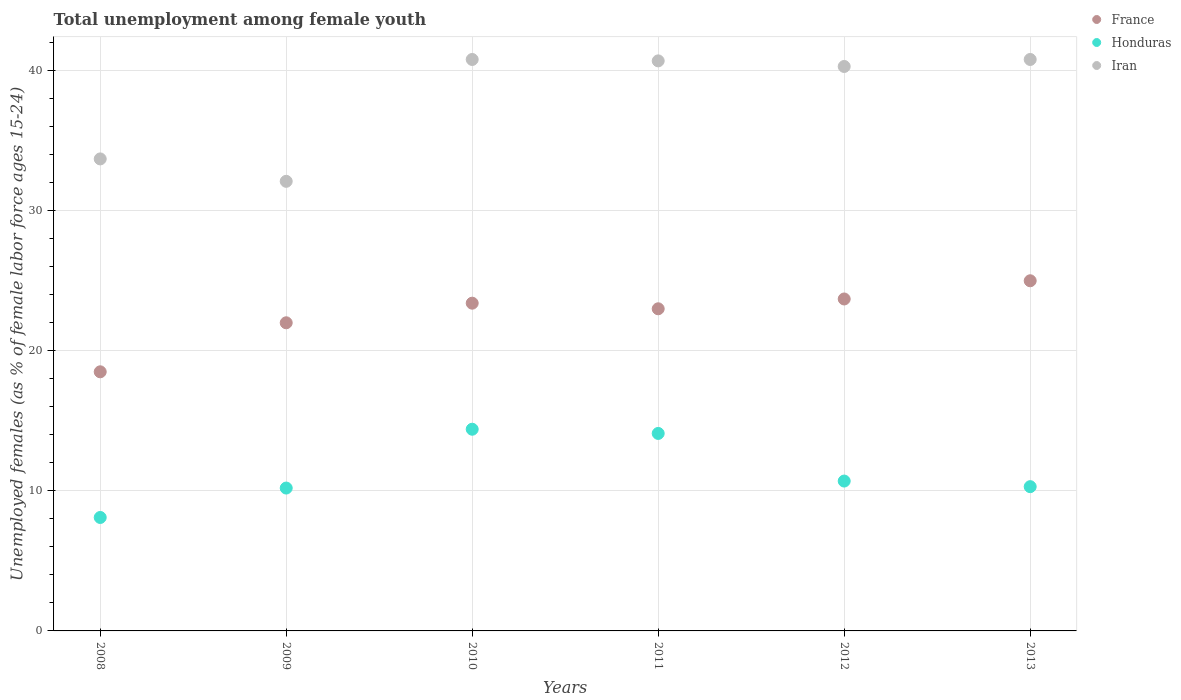Is the number of dotlines equal to the number of legend labels?
Ensure brevity in your answer.  Yes. What is the percentage of unemployed females in in Honduras in 2010?
Your answer should be very brief. 14.4. Across all years, what is the maximum percentage of unemployed females in in Honduras?
Provide a succinct answer. 14.4. In which year was the percentage of unemployed females in in France maximum?
Provide a succinct answer. 2013. What is the total percentage of unemployed females in in France in the graph?
Your answer should be compact. 135.6. What is the difference between the percentage of unemployed females in in Iran in 2009 and that in 2013?
Provide a succinct answer. -8.7. What is the difference between the percentage of unemployed females in in France in 2013 and the percentage of unemployed females in in Honduras in 2008?
Offer a very short reply. 16.9. What is the average percentage of unemployed females in in Iran per year?
Your answer should be very brief. 38.07. In the year 2009, what is the difference between the percentage of unemployed females in in Iran and percentage of unemployed females in in France?
Offer a terse response. 10.1. What is the ratio of the percentage of unemployed females in in Iran in 2008 to that in 2010?
Give a very brief answer. 0.83. Is the percentage of unemployed females in in Iran in 2009 less than that in 2013?
Your response must be concise. Yes. What is the difference between the highest and the second highest percentage of unemployed females in in France?
Ensure brevity in your answer.  1.3. Is it the case that in every year, the sum of the percentage of unemployed females in in Iran and percentage of unemployed females in in Honduras  is greater than the percentage of unemployed females in in France?
Keep it short and to the point. Yes. Does the percentage of unemployed females in in France monotonically increase over the years?
Ensure brevity in your answer.  No. Is the percentage of unemployed females in in Honduras strictly greater than the percentage of unemployed females in in Iran over the years?
Your answer should be very brief. No. How many dotlines are there?
Your answer should be compact. 3. How many years are there in the graph?
Ensure brevity in your answer.  6. What is the difference between two consecutive major ticks on the Y-axis?
Your answer should be very brief. 10. Are the values on the major ticks of Y-axis written in scientific E-notation?
Keep it short and to the point. No. Does the graph contain grids?
Give a very brief answer. Yes. Where does the legend appear in the graph?
Make the answer very short. Top right. How many legend labels are there?
Ensure brevity in your answer.  3. What is the title of the graph?
Ensure brevity in your answer.  Total unemployment among female youth. Does "Comoros" appear as one of the legend labels in the graph?
Make the answer very short. No. What is the label or title of the X-axis?
Ensure brevity in your answer.  Years. What is the label or title of the Y-axis?
Offer a terse response. Unemployed females (as % of female labor force ages 15-24). What is the Unemployed females (as % of female labor force ages 15-24) of France in 2008?
Offer a very short reply. 18.5. What is the Unemployed females (as % of female labor force ages 15-24) of Honduras in 2008?
Offer a terse response. 8.1. What is the Unemployed females (as % of female labor force ages 15-24) of Iran in 2008?
Make the answer very short. 33.7. What is the Unemployed females (as % of female labor force ages 15-24) of France in 2009?
Provide a short and direct response. 22. What is the Unemployed females (as % of female labor force ages 15-24) of Honduras in 2009?
Provide a succinct answer. 10.2. What is the Unemployed females (as % of female labor force ages 15-24) of Iran in 2009?
Your answer should be compact. 32.1. What is the Unemployed females (as % of female labor force ages 15-24) in France in 2010?
Keep it short and to the point. 23.4. What is the Unemployed females (as % of female labor force ages 15-24) in Honduras in 2010?
Your response must be concise. 14.4. What is the Unemployed females (as % of female labor force ages 15-24) of Iran in 2010?
Your answer should be very brief. 40.8. What is the Unemployed females (as % of female labor force ages 15-24) of Honduras in 2011?
Offer a very short reply. 14.1. What is the Unemployed females (as % of female labor force ages 15-24) in Iran in 2011?
Your answer should be very brief. 40.7. What is the Unemployed females (as % of female labor force ages 15-24) of France in 2012?
Your answer should be very brief. 23.7. What is the Unemployed females (as % of female labor force ages 15-24) in Honduras in 2012?
Keep it short and to the point. 10.7. What is the Unemployed females (as % of female labor force ages 15-24) in Iran in 2012?
Give a very brief answer. 40.3. What is the Unemployed females (as % of female labor force ages 15-24) of France in 2013?
Provide a short and direct response. 25. What is the Unemployed females (as % of female labor force ages 15-24) in Honduras in 2013?
Provide a short and direct response. 10.3. What is the Unemployed females (as % of female labor force ages 15-24) in Iran in 2013?
Your response must be concise. 40.8. Across all years, what is the maximum Unemployed females (as % of female labor force ages 15-24) of Honduras?
Make the answer very short. 14.4. Across all years, what is the maximum Unemployed females (as % of female labor force ages 15-24) in Iran?
Ensure brevity in your answer.  40.8. Across all years, what is the minimum Unemployed females (as % of female labor force ages 15-24) in Honduras?
Offer a very short reply. 8.1. Across all years, what is the minimum Unemployed females (as % of female labor force ages 15-24) of Iran?
Provide a succinct answer. 32.1. What is the total Unemployed females (as % of female labor force ages 15-24) of France in the graph?
Offer a terse response. 135.6. What is the total Unemployed females (as % of female labor force ages 15-24) in Honduras in the graph?
Offer a terse response. 67.8. What is the total Unemployed females (as % of female labor force ages 15-24) of Iran in the graph?
Give a very brief answer. 228.4. What is the difference between the Unemployed females (as % of female labor force ages 15-24) in Honduras in 2008 and that in 2009?
Ensure brevity in your answer.  -2.1. What is the difference between the Unemployed females (as % of female labor force ages 15-24) of Iran in 2008 and that in 2009?
Your answer should be compact. 1.6. What is the difference between the Unemployed females (as % of female labor force ages 15-24) in Honduras in 2008 and that in 2010?
Ensure brevity in your answer.  -6.3. What is the difference between the Unemployed females (as % of female labor force ages 15-24) of France in 2008 and that in 2011?
Offer a very short reply. -4.5. What is the difference between the Unemployed females (as % of female labor force ages 15-24) in Honduras in 2008 and that in 2011?
Make the answer very short. -6. What is the difference between the Unemployed females (as % of female labor force ages 15-24) of Iran in 2008 and that in 2011?
Offer a very short reply. -7. What is the difference between the Unemployed females (as % of female labor force ages 15-24) in France in 2008 and that in 2013?
Give a very brief answer. -6.5. What is the difference between the Unemployed females (as % of female labor force ages 15-24) of France in 2009 and that in 2011?
Your response must be concise. -1. What is the difference between the Unemployed females (as % of female labor force ages 15-24) in Honduras in 2009 and that in 2012?
Your answer should be very brief. -0.5. What is the difference between the Unemployed females (as % of female labor force ages 15-24) of Iran in 2009 and that in 2012?
Provide a succinct answer. -8.2. What is the difference between the Unemployed females (as % of female labor force ages 15-24) of France in 2009 and that in 2013?
Give a very brief answer. -3. What is the difference between the Unemployed females (as % of female labor force ages 15-24) of Honduras in 2009 and that in 2013?
Your answer should be very brief. -0.1. What is the difference between the Unemployed females (as % of female labor force ages 15-24) of Honduras in 2010 and that in 2011?
Offer a very short reply. 0.3. What is the difference between the Unemployed females (as % of female labor force ages 15-24) of Iran in 2010 and that in 2011?
Your answer should be compact. 0.1. What is the difference between the Unemployed females (as % of female labor force ages 15-24) in France in 2010 and that in 2012?
Provide a short and direct response. -0.3. What is the difference between the Unemployed females (as % of female labor force ages 15-24) in Iran in 2010 and that in 2012?
Keep it short and to the point. 0.5. What is the difference between the Unemployed females (as % of female labor force ages 15-24) in France in 2010 and that in 2013?
Make the answer very short. -1.6. What is the difference between the Unemployed females (as % of female labor force ages 15-24) in Honduras in 2010 and that in 2013?
Your response must be concise. 4.1. What is the difference between the Unemployed females (as % of female labor force ages 15-24) of Honduras in 2011 and that in 2012?
Offer a very short reply. 3.4. What is the difference between the Unemployed females (as % of female labor force ages 15-24) in Iran in 2011 and that in 2013?
Provide a succinct answer. -0.1. What is the difference between the Unemployed females (as % of female labor force ages 15-24) in France in 2012 and that in 2013?
Offer a very short reply. -1.3. What is the difference between the Unemployed females (as % of female labor force ages 15-24) of Honduras in 2012 and that in 2013?
Ensure brevity in your answer.  0.4. What is the difference between the Unemployed females (as % of female labor force ages 15-24) in Iran in 2012 and that in 2013?
Make the answer very short. -0.5. What is the difference between the Unemployed females (as % of female labor force ages 15-24) of France in 2008 and the Unemployed females (as % of female labor force ages 15-24) of Honduras in 2009?
Offer a terse response. 8.3. What is the difference between the Unemployed females (as % of female labor force ages 15-24) in France in 2008 and the Unemployed females (as % of female labor force ages 15-24) in Iran in 2010?
Ensure brevity in your answer.  -22.3. What is the difference between the Unemployed females (as % of female labor force ages 15-24) in Honduras in 2008 and the Unemployed females (as % of female labor force ages 15-24) in Iran in 2010?
Offer a very short reply. -32.7. What is the difference between the Unemployed females (as % of female labor force ages 15-24) in France in 2008 and the Unemployed females (as % of female labor force ages 15-24) in Honduras in 2011?
Give a very brief answer. 4.4. What is the difference between the Unemployed females (as % of female labor force ages 15-24) of France in 2008 and the Unemployed females (as % of female labor force ages 15-24) of Iran in 2011?
Your answer should be compact. -22.2. What is the difference between the Unemployed females (as % of female labor force ages 15-24) of Honduras in 2008 and the Unemployed females (as % of female labor force ages 15-24) of Iran in 2011?
Keep it short and to the point. -32.6. What is the difference between the Unemployed females (as % of female labor force ages 15-24) of France in 2008 and the Unemployed females (as % of female labor force ages 15-24) of Iran in 2012?
Your response must be concise. -21.8. What is the difference between the Unemployed females (as % of female labor force ages 15-24) in Honduras in 2008 and the Unemployed females (as % of female labor force ages 15-24) in Iran in 2012?
Your answer should be very brief. -32.2. What is the difference between the Unemployed females (as % of female labor force ages 15-24) in France in 2008 and the Unemployed females (as % of female labor force ages 15-24) in Honduras in 2013?
Offer a very short reply. 8.2. What is the difference between the Unemployed females (as % of female labor force ages 15-24) of France in 2008 and the Unemployed females (as % of female labor force ages 15-24) of Iran in 2013?
Your response must be concise. -22.3. What is the difference between the Unemployed females (as % of female labor force ages 15-24) of Honduras in 2008 and the Unemployed females (as % of female labor force ages 15-24) of Iran in 2013?
Give a very brief answer. -32.7. What is the difference between the Unemployed females (as % of female labor force ages 15-24) in France in 2009 and the Unemployed females (as % of female labor force ages 15-24) in Iran in 2010?
Your response must be concise. -18.8. What is the difference between the Unemployed females (as % of female labor force ages 15-24) in Honduras in 2009 and the Unemployed females (as % of female labor force ages 15-24) in Iran in 2010?
Provide a succinct answer. -30.6. What is the difference between the Unemployed females (as % of female labor force ages 15-24) of France in 2009 and the Unemployed females (as % of female labor force ages 15-24) of Honduras in 2011?
Your answer should be very brief. 7.9. What is the difference between the Unemployed females (as % of female labor force ages 15-24) in France in 2009 and the Unemployed females (as % of female labor force ages 15-24) in Iran in 2011?
Give a very brief answer. -18.7. What is the difference between the Unemployed females (as % of female labor force ages 15-24) of Honduras in 2009 and the Unemployed females (as % of female labor force ages 15-24) of Iran in 2011?
Make the answer very short. -30.5. What is the difference between the Unemployed females (as % of female labor force ages 15-24) in France in 2009 and the Unemployed females (as % of female labor force ages 15-24) in Honduras in 2012?
Make the answer very short. 11.3. What is the difference between the Unemployed females (as % of female labor force ages 15-24) of France in 2009 and the Unemployed females (as % of female labor force ages 15-24) of Iran in 2012?
Ensure brevity in your answer.  -18.3. What is the difference between the Unemployed females (as % of female labor force ages 15-24) of Honduras in 2009 and the Unemployed females (as % of female labor force ages 15-24) of Iran in 2012?
Provide a short and direct response. -30.1. What is the difference between the Unemployed females (as % of female labor force ages 15-24) in France in 2009 and the Unemployed females (as % of female labor force ages 15-24) in Iran in 2013?
Your answer should be compact. -18.8. What is the difference between the Unemployed females (as % of female labor force ages 15-24) in Honduras in 2009 and the Unemployed females (as % of female labor force ages 15-24) in Iran in 2013?
Provide a succinct answer. -30.6. What is the difference between the Unemployed females (as % of female labor force ages 15-24) of France in 2010 and the Unemployed females (as % of female labor force ages 15-24) of Iran in 2011?
Give a very brief answer. -17.3. What is the difference between the Unemployed females (as % of female labor force ages 15-24) of Honduras in 2010 and the Unemployed females (as % of female labor force ages 15-24) of Iran in 2011?
Provide a succinct answer. -26.3. What is the difference between the Unemployed females (as % of female labor force ages 15-24) of France in 2010 and the Unemployed females (as % of female labor force ages 15-24) of Honduras in 2012?
Provide a succinct answer. 12.7. What is the difference between the Unemployed females (as % of female labor force ages 15-24) in France in 2010 and the Unemployed females (as % of female labor force ages 15-24) in Iran in 2012?
Keep it short and to the point. -16.9. What is the difference between the Unemployed females (as % of female labor force ages 15-24) in Honduras in 2010 and the Unemployed females (as % of female labor force ages 15-24) in Iran in 2012?
Give a very brief answer. -25.9. What is the difference between the Unemployed females (as % of female labor force ages 15-24) of France in 2010 and the Unemployed females (as % of female labor force ages 15-24) of Iran in 2013?
Provide a succinct answer. -17.4. What is the difference between the Unemployed females (as % of female labor force ages 15-24) in Honduras in 2010 and the Unemployed females (as % of female labor force ages 15-24) in Iran in 2013?
Ensure brevity in your answer.  -26.4. What is the difference between the Unemployed females (as % of female labor force ages 15-24) in France in 2011 and the Unemployed females (as % of female labor force ages 15-24) in Honduras in 2012?
Your answer should be compact. 12.3. What is the difference between the Unemployed females (as % of female labor force ages 15-24) in France in 2011 and the Unemployed females (as % of female labor force ages 15-24) in Iran in 2012?
Keep it short and to the point. -17.3. What is the difference between the Unemployed females (as % of female labor force ages 15-24) of Honduras in 2011 and the Unemployed females (as % of female labor force ages 15-24) of Iran in 2012?
Keep it short and to the point. -26.2. What is the difference between the Unemployed females (as % of female labor force ages 15-24) of France in 2011 and the Unemployed females (as % of female labor force ages 15-24) of Honduras in 2013?
Offer a very short reply. 12.7. What is the difference between the Unemployed females (as % of female labor force ages 15-24) of France in 2011 and the Unemployed females (as % of female labor force ages 15-24) of Iran in 2013?
Provide a succinct answer. -17.8. What is the difference between the Unemployed females (as % of female labor force ages 15-24) in Honduras in 2011 and the Unemployed females (as % of female labor force ages 15-24) in Iran in 2013?
Offer a very short reply. -26.7. What is the difference between the Unemployed females (as % of female labor force ages 15-24) in France in 2012 and the Unemployed females (as % of female labor force ages 15-24) in Honduras in 2013?
Your response must be concise. 13.4. What is the difference between the Unemployed females (as % of female labor force ages 15-24) in France in 2012 and the Unemployed females (as % of female labor force ages 15-24) in Iran in 2013?
Keep it short and to the point. -17.1. What is the difference between the Unemployed females (as % of female labor force ages 15-24) of Honduras in 2012 and the Unemployed females (as % of female labor force ages 15-24) of Iran in 2013?
Provide a succinct answer. -30.1. What is the average Unemployed females (as % of female labor force ages 15-24) in France per year?
Give a very brief answer. 22.6. What is the average Unemployed females (as % of female labor force ages 15-24) in Iran per year?
Provide a short and direct response. 38.07. In the year 2008, what is the difference between the Unemployed females (as % of female labor force ages 15-24) of France and Unemployed females (as % of female labor force ages 15-24) of Iran?
Offer a terse response. -15.2. In the year 2008, what is the difference between the Unemployed females (as % of female labor force ages 15-24) of Honduras and Unemployed females (as % of female labor force ages 15-24) of Iran?
Offer a terse response. -25.6. In the year 2009, what is the difference between the Unemployed females (as % of female labor force ages 15-24) in France and Unemployed females (as % of female labor force ages 15-24) in Honduras?
Your response must be concise. 11.8. In the year 2009, what is the difference between the Unemployed females (as % of female labor force ages 15-24) in France and Unemployed females (as % of female labor force ages 15-24) in Iran?
Make the answer very short. -10.1. In the year 2009, what is the difference between the Unemployed females (as % of female labor force ages 15-24) of Honduras and Unemployed females (as % of female labor force ages 15-24) of Iran?
Ensure brevity in your answer.  -21.9. In the year 2010, what is the difference between the Unemployed females (as % of female labor force ages 15-24) of France and Unemployed females (as % of female labor force ages 15-24) of Honduras?
Your response must be concise. 9. In the year 2010, what is the difference between the Unemployed females (as % of female labor force ages 15-24) of France and Unemployed females (as % of female labor force ages 15-24) of Iran?
Offer a terse response. -17.4. In the year 2010, what is the difference between the Unemployed females (as % of female labor force ages 15-24) in Honduras and Unemployed females (as % of female labor force ages 15-24) in Iran?
Make the answer very short. -26.4. In the year 2011, what is the difference between the Unemployed females (as % of female labor force ages 15-24) of France and Unemployed females (as % of female labor force ages 15-24) of Honduras?
Your answer should be compact. 8.9. In the year 2011, what is the difference between the Unemployed females (as % of female labor force ages 15-24) of France and Unemployed females (as % of female labor force ages 15-24) of Iran?
Provide a succinct answer. -17.7. In the year 2011, what is the difference between the Unemployed females (as % of female labor force ages 15-24) of Honduras and Unemployed females (as % of female labor force ages 15-24) of Iran?
Keep it short and to the point. -26.6. In the year 2012, what is the difference between the Unemployed females (as % of female labor force ages 15-24) of France and Unemployed females (as % of female labor force ages 15-24) of Honduras?
Provide a succinct answer. 13. In the year 2012, what is the difference between the Unemployed females (as % of female labor force ages 15-24) in France and Unemployed females (as % of female labor force ages 15-24) in Iran?
Make the answer very short. -16.6. In the year 2012, what is the difference between the Unemployed females (as % of female labor force ages 15-24) of Honduras and Unemployed females (as % of female labor force ages 15-24) of Iran?
Keep it short and to the point. -29.6. In the year 2013, what is the difference between the Unemployed females (as % of female labor force ages 15-24) of France and Unemployed females (as % of female labor force ages 15-24) of Iran?
Provide a succinct answer. -15.8. In the year 2013, what is the difference between the Unemployed females (as % of female labor force ages 15-24) of Honduras and Unemployed females (as % of female labor force ages 15-24) of Iran?
Offer a very short reply. -30.5. What is the ratio of the Unemployed females (as % of female labor force ages 15-24) in France in 2008 to that in 2009?
Give a very brief answer. 0.84. What is the ratio of the Unemployed females (as % of female labor force ages 15-24) in Honduras in 2008 to that in 2009?
Offer a very short reply. 0.79. What is the ratio of the Unemployed females (as % of female labor force ages 15-24) in Iran in 2008 to that in 2009?
Your answer should be compact. 1.05. What is the ratio of the Unemployed females (as % of female labor force ages 15-24) of France in 2008 to that in 2010?
Keep it short and to the point. 0.79. What is the ratio of the Unemployed females (as % of female labor force ages 15-24) of Honduras in 2008 to that in 2010?
Your answer should be very brief. 0.56. What is the ratio of the Unemployed females (as % of female labor force ages 15-24) of Iran in 2008 to that in 2010?
Keep it short and to the point. 0.83. What is the ratio of the Unemployed females (as % of female labor force ages 15-24) of France in 2008 to that in 2011?
Keep it short and to the point. 0.8. What is the ratio of the Unemployed females (as % of female labor force ages 15-24) of Honduras in 2008 to that in 2011?
Provide a short and direct response. 0.57. What is the ratio of the Unemployed females (as % of female labor force ages 15-24) in Iran in 2008 to that in 2011?
Provide a succinct answer. 0.83. What is the ratio of the Unemployed females (as % of female labor force ages 15-24) of France in 2008 to that in 2012?
Provide a short and direct response. 0.78. What is the ratio of the Unemployed females (as % of female labor force ages 15-24) of Honduras in 2008 to that in 2012?
Keep it short and to the point. 0.76. What is the ratio of the Unemployed females (as % of female labor force ages 15-24) in Iran in 2008 to that in 2012?
Give a very brief answer. 0.84. What is the ratio of the Unemployed females (as % of female labor force ages 15-24) of France in 2008 to that in 2013?
Provide a succinct answer. 0.74. What is the ratio of the Unemployed females (as % of female labor force ages 15-24) in Honduras in 2008 to that in 2013?
Ensure brevity in your answer.  0.79. What is the ratio of the Unemployed females (as % of female labor force ages 15-24) of Iran in 2008 to that in 2013?
Offer a very short reply. 0.83. What is the ratio of the Unemployed females (as % of female labor force ages 15-24) of France in 2009 to that in 2010?
Keep it short and to the point. 0.94. What is the ratio of the Unemployed females (as % of female labor force ages 15-24) of Honduras in 2009 to that in 2010?
Provide a succinct answer. 0.71. What is the ratio of the Unemployed females (as % of female labor force ages 15-24) of Iran in 2009 to that in 2010?
Provide a succinct answer. 0.79. What is the ratio of the Unemployed females (as % of female labor force ages 15-24) of France in 2009 to that in 2011?
Give a very brief answer. 0.96. What is the ratio of the Unemployed females (as % of female labor force ages 15-24) in Honduras in 2009 to that in 2011?
Provide a short and direct response. 0.72. What is the ratio of the Unemployed females (as % of female labor force ages 15-24) of Iran in 2009 to that in 2011?
Your answer should be compact. 0.79. What is the ratio of the Unemployed females (as % of female labor force ages 15-24) of France in 2009 to that in 2012?
Your answer should be very brief. 0.93. What is the ratio of the Unemployed females (as % of female labor force ages 15-24) of Honduras in 2009 to that in 2012?
Your response must be concise. 0.95. What is the ratio of the Unemployed females (as % of female labor force ages 15-24) in Iran in 2009 to that in 2012?
Your answer should be very brief. 0.8. What is the ratio of the Unemployed females (as % of female labor force ages 15-24) in France in 2009 to that in 2013?
Give a very brief answer. 0.88. What is the ratio of the Unemployed females (as % of female labor force ages 15-24) in Honduras in 2009 to that in 2013?
Ensure brevity in your answer.  0.99. What is the ratio of the Unemployed females (as % of female labor force ages 15-24) in Iran in 2009 to that in 2013?
Your answer should be compact. 0.79. What is the ratio of the Unemployed females (as % of female labor force ages 15-24) of France in 2010 to that in 2011?
Your answer should be compact. 1.02. What is the ratio of the Unemployed females (as % of female labor force ages 15-24) in Honduras in 2010 to that in 2011?
Keep it short and to the point. 1.02. What is the ratio of the Unemployed females (as % of female labor force ages 15-24) of Iran in 2010 to that in 2011?
Make the answer very short. 1. What is the ratio of the Unemployed females (as % of female labor force ages 15-24) in France in 2010 to that in 2012?
Provide a succinct answer. 0.99. What is the ratio of the Unemployed females (as % of female labor force ages 15-24) of Honduras in 2010 to that in 2012?
Give a very brief answer. 1.35. What is the ratio of the Unemployed females (as % of female labor force ages 15-24) of Iran in 2010 to that in 2012?
Offer a very short reply. 1.01. What is the ratio of the Unemployed females (as % of female labor force ages 15-24) in France in 2010 to that in 2013?
Your answer should be compact. 0.94. What is the ratio of the Unemployed females (as % of female labor force ages 15-24) in Honduras in 2010 to that in 2013?
Your answer should be very brief. 1.4. What is the ratio of the Unemployed females (as % of female labor force ages 15-24) in France in 2011 to that in 2012?
Give a very brief answer. 0.97. What is the ratio of the Unemployed females (as % of female labor force ages 15-24) of Honduras in 2011 to that in 2012?
Offer a very short reply. 1.32. What is the ratio of the Unemployed females (as % of female labor force ages 15-24) in Iran in 2011 to that in 2012?
Provide a short and direct response. 1.01. What is the ratio of the Unemployed females (as % of female labor force ages 15-24) in France in 2011 to that in 2013?
Provide a succinct answer. 0.92. What is the ratio of the Unemployed females (as % of female labor force ages 15-24) in Honduras in 2011 to that in 2013?
Provide a succinct answer. 1.37. What is the ratio of the Unemployed females (as % of female labor force ages 15-24) of Iran in 2011 to that in 2013?
Your answer should be compact. 1. What is the ratio of the Unemployed females (as % of female labor force ages 15-24) in France in 2012 to that in 2013?
Offer a very short reply. 0.95. What is the ratio of the Unemployed females (as % of female labor force ages 15-24) of Honduras in 2012 to that in 2013?
Your answer should be very brief. 1.04. What is the difference between the highest and the second highest Unemployed females (as % of female labor force ages 15-24) of Honduras?
Ensure brevity in your answer.  0.3. What is the difference between the highest and the lowest Unemployed females (as % of female labor force ages 15-24) in France?
Provide a succinct answer. 6.5. 